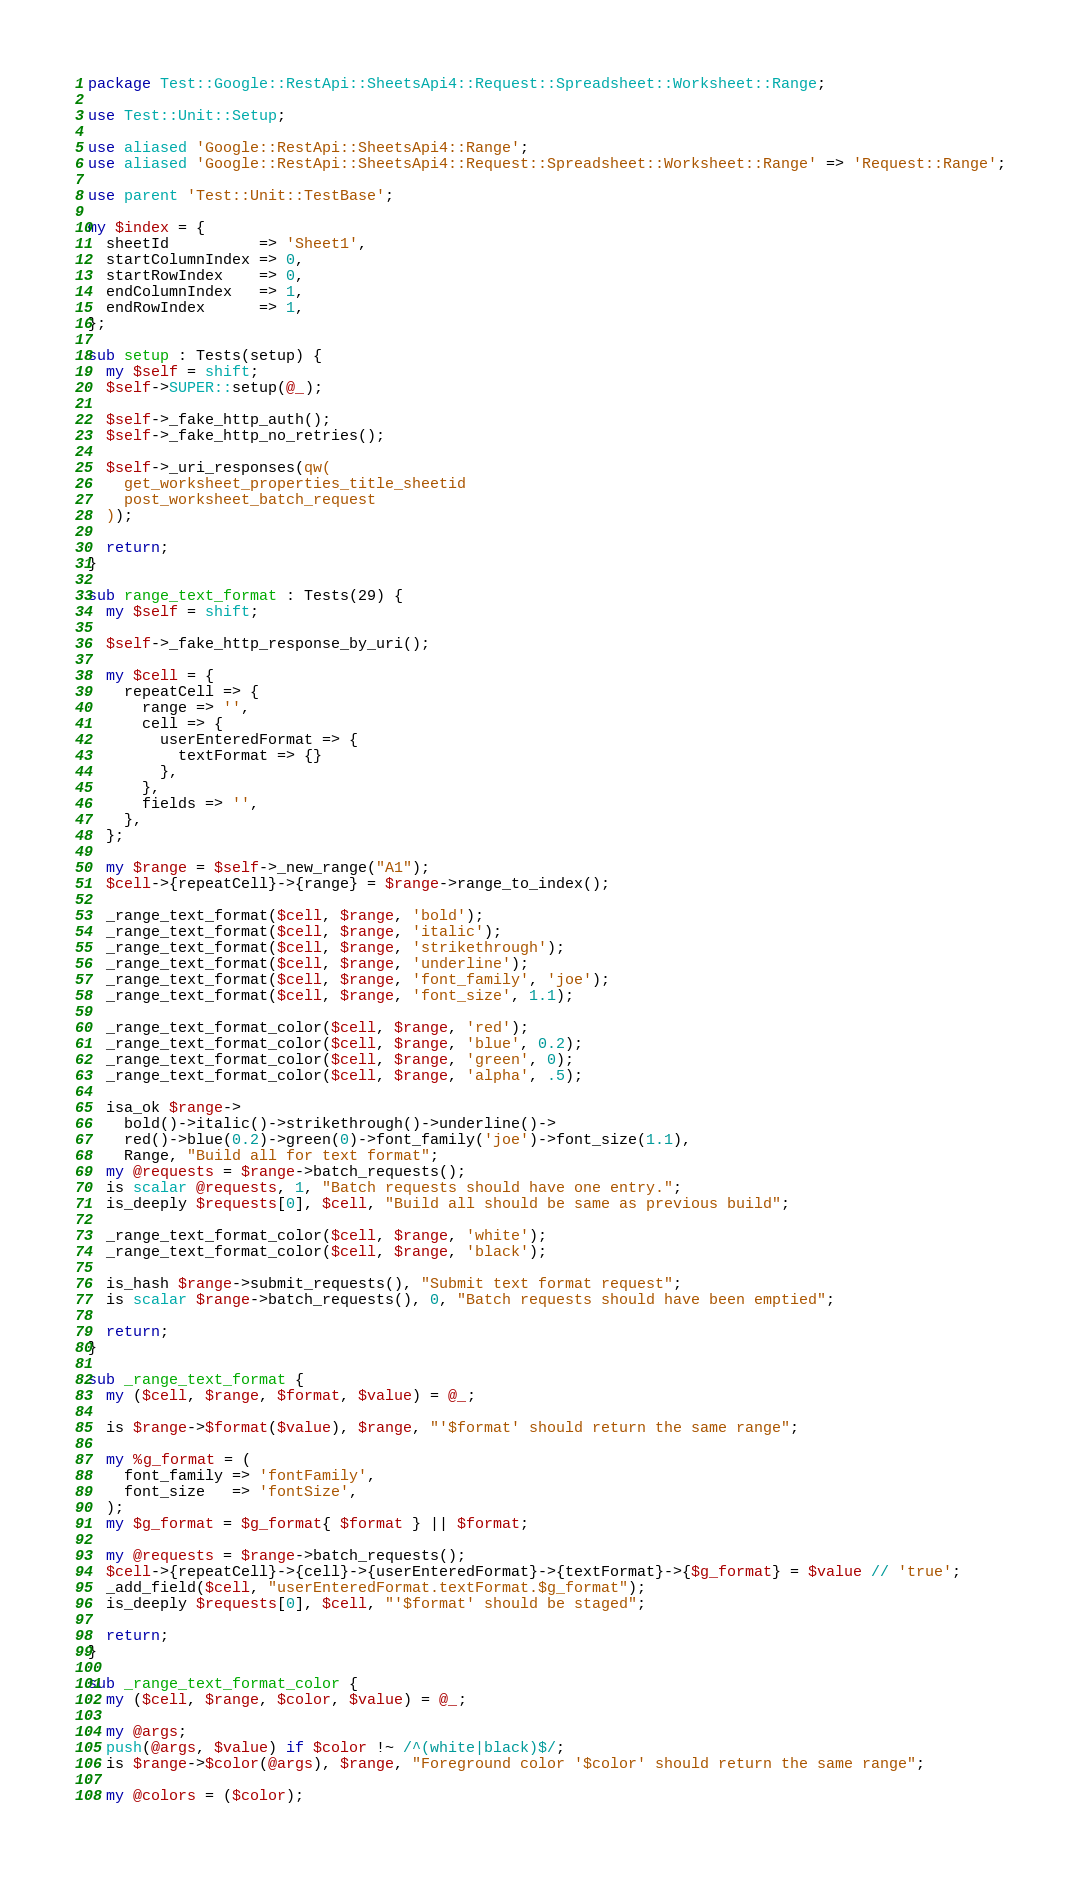Convert code to text. <code><loc_0><loc_0><loc_500><loc_500><_Perl_>package Test::Google::RestApi::SheetsApi4::Request::Spreadsheet::Worksheet::Range;

use Test::Unit::Setup;

use aliased 'Google::RestApi::SheetsApi4::Range';
use aliased 'Google::RestApi::SheetsApi4::Request::Spreadsheet::Worksheet::Range' => 'Request::Range';

use parent 'Test::Unit::TestBase';

my $index = {
  sheetId          => 'Sheet1',
  startColumnIndex => 0,
  startRowIndex    => 0,
  endColumnIndex   => 1,
  endRowIndex      => 1,
};

sub setup : Tests(setup) {
  my $self = shift;
  $self->SUPER::setup(@_);

  $self->_fake_http_auth();
  $self->_fake_http_no_retries();

  $self->_uri_responses(qw(
    get_worksheet_properties_title_sheetid
    post_worksheet_batch_request
  ));

  return;
}

sub range_text_format : Tests(29) {
  my $self = shift;

  $self->_fake_http_response_by_uri();

  my $cell = {
    repeatCell => {
      range => '',
      cell => {
        userEnteredFormat => {
          textFormat => {}
        },
      },
      fields => '',
    },
  };

  my $range = $self->_new_range("A1");
  $cell->{repeatCell}->{range} = $range->range_to_index();

  _range_text_format($cell, $range, 'bold');
  _range_text_format($cell, $range, 'italic');
  _range_text_format($cell, $range, 'strikethrough');
  _range_text_format($cell, $range, 'underline');
  _range_text_format($cell, $range, 'font_family', 'joe');
  _range_text_format($cell, $range, 'font_size', 1.1);

  _range_text_format_color($cell, $range, 'red');
  _range_text_format_color($cell, $range, 'blue', 0.2);
  _range_text_format_color($cell, $range, 'green', 0);
  _range_text_format_color($cell, $range, 'alpha', .5);

  isa_ok $range->
    bold()->italic()->strikethrough()->underline()->
    red()->blue(0.2)->green(0)->font_family('joe')->font_size(1.1),
    Range, "Build all for text format";
  my @requests = $range->batch_requests();
  is scalar @requests, 1, "Batch requests should have one entry.";
  is_deeply $requests[0], $cell, "Build all should be same as previous build";

  _range_text_format_color($cell, $range, 'white');
  _range_text_format_color($cell, $range, 'black');

  is_hash $range->submit_requests(), "Submit text format request";
  is scalar $range->batch_requests(), 0, "Batch requests should have been emptied";

  return;
}

sub _range_text_format {
  my ($cell, $range, $format, $value) = @_;

  is $range->$format($value), $range, "'$format' should return the same range";

  my %g_format = (
    font_family => 'fontFamily',
    font_size   => 'fontSize',
  );
  my $g_format = $g_format{ $format } || $format;

  my @requests = $range->batch_requests();
  $cell->{repeatCell}->{cell}->{userEnteredFormat}->{textFormat}->{$g_format} = $value // 'true';
  _add_field($cell, "userEnteredFormat.textFormat.$g_format");
  is_deeply $requests[0], $cell, "'$format' should be staged";

  return;
}

sub _range_text_format_color {
  my ($cell, $range, $color, $value) = @_;

  my @args;
  push(@args, $value) if $color !~ /^(white|black)$/;
  is $range->$color(@args), $range, "Foreground color '$color' should return the same range";

  my @colors = ($color);</code> 